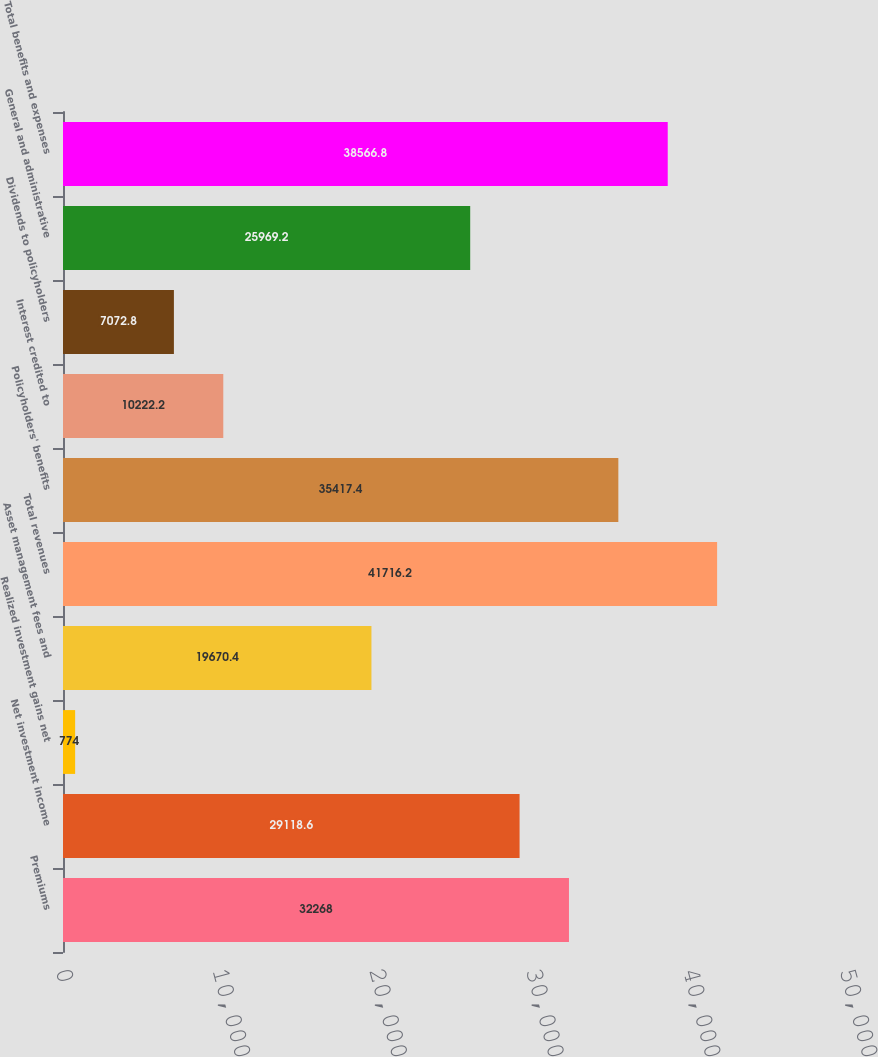<chart> <loc_0><loc_0><loc_500><loc_500><bar_chart><fcel>Premiums<fcel>Net investment income<fcel>Realized investment gains net<fcel>Asset management fees and<fcel>Total revenues<fcel>Policyholders' benefits<fcel>Interest credited to<fcel>Dividends to policyholders<fcel>General and administrative<fcel>Total benefits and expenses<nl><fcel>32268<fcel>29118.6<fcel>774<fcel>19670.4<fcel>41716.2<fcel>35417.4<fcel>10222.2<fcel>7072.8<fcel>25969.2<fcel>38566.8<nl></chart> 